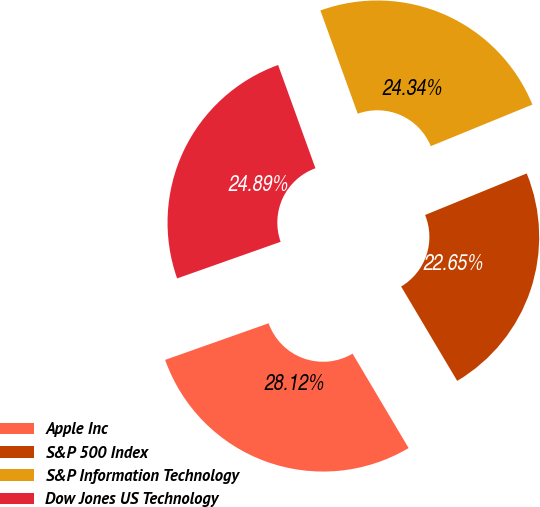<chart> <loc_0><loc_0><loc_500><loc_500><pie_chart><fcel>Apple Inc<fcel>S&P 500 Index<fcel>S&P Information Technology<fcel>Dow Jones US Technology<nl><fcel>28.12%<fcel>22.65%<fcel>24.34%<fcel>24.89%<nl></chart> 